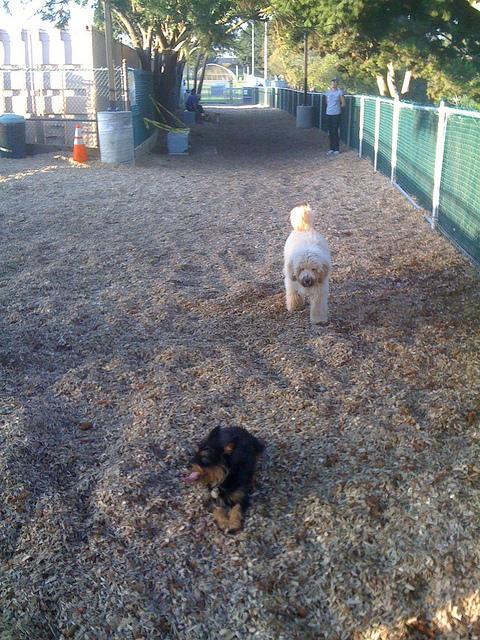Are those trees were the woman is standing?
Quick response, please. Yes. Is the woman fat or thin?
Be succinct. Thin. What color is the bigger dog?
Be succinct. White. 